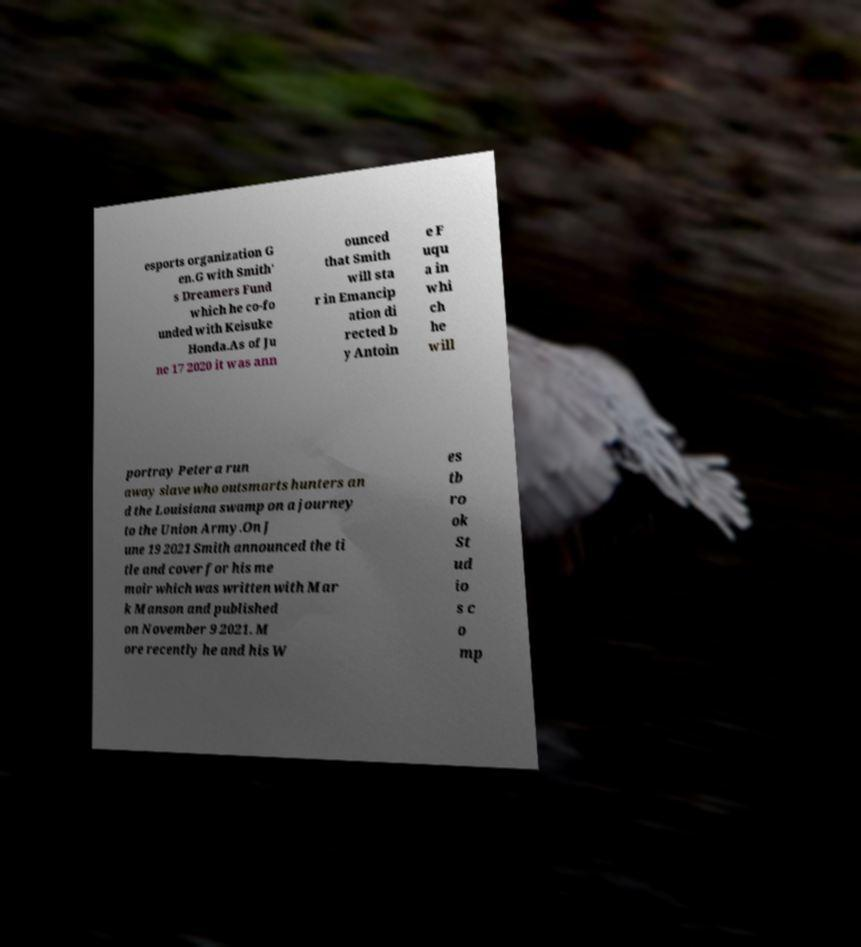Could you extract and type out the text from this image? esports organization G en.G with Smith' s Dreamers Fund which he co-fo unded with Keisuke Honda.As of Ju ne 17 2020 it was ann ounced that Smith will sta r in Emancip ation di rected b y Antoin e F uqu a in whi ch he will portray Peter a run away slave who outsmarts hunters an d the Louisiana swamp on a journey to the Union Army.On J une 19 2021 Smith announced the ti tle and cover for his me moir which was written with Mar k Manson and published on November 9 2021. M ore recently he and his W es tb ro ok St ud io s c o mp 